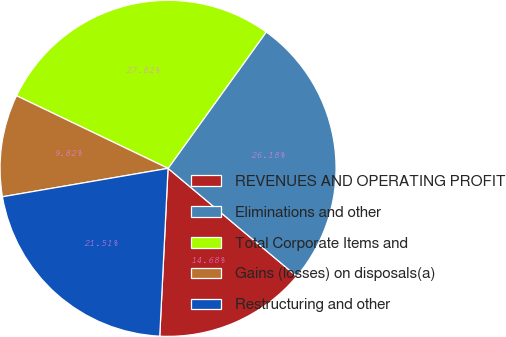Convert chart. <chart><loc_0><loc_0><loc_500><loc_500><pie_chart><fcel>REVENUES AND OPERATING PROFIT<fcel>Eliminations and other<fcel>Total Corporate Items and<fcel>Gains (losses) on disposals(a)<fcel>Restructuring and other<nl><fcel>14.68%<fcel>26.18%<fcel>27.82%<fcel>9.82%<fcel>21.51%<nl></chart> 